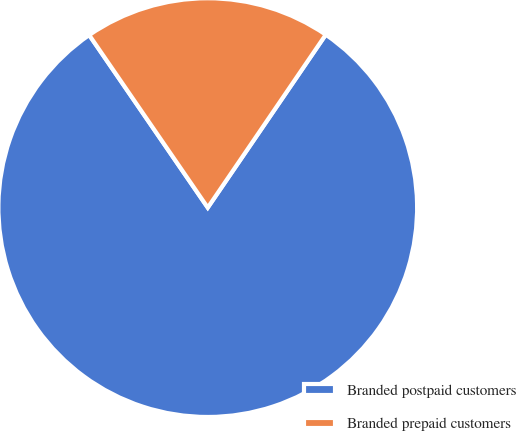Convert chart. <chart><loc_0><loc_0><loc_500><loc_500><pie_chart><fcel>Branded postpaid customers<fcel>Branded prepaid customers<nl><fcel>80.89%<fcel>19.11%<nl></chart> 